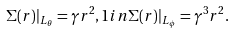Convert formula to latex. <formula><loc_0><loc_0><loc_500><loc_500>\Sigma ( r ) | _ { L _ { \theta } } = \gamma r ^ { 2 } , 1 i n \Sigma ( r ) | _ { L _ { \phi } } = \gamma ^ { 3 } r ^ { 2 } .</formula> 